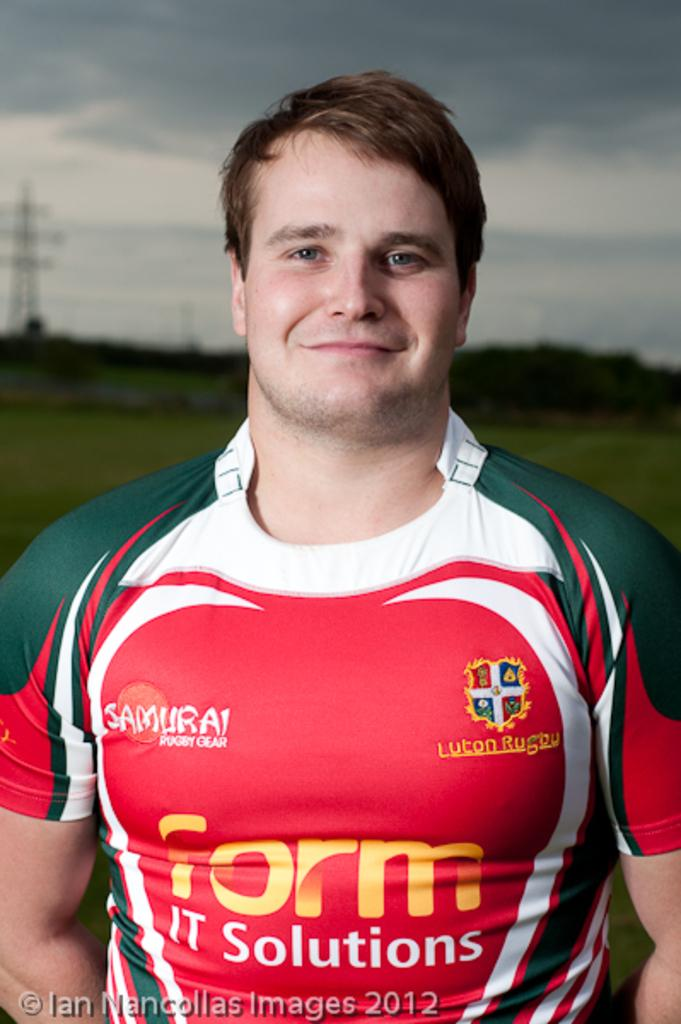<image>
Present a compact description of the photo's key features. A rugby player wears an ad for IT solutions. 